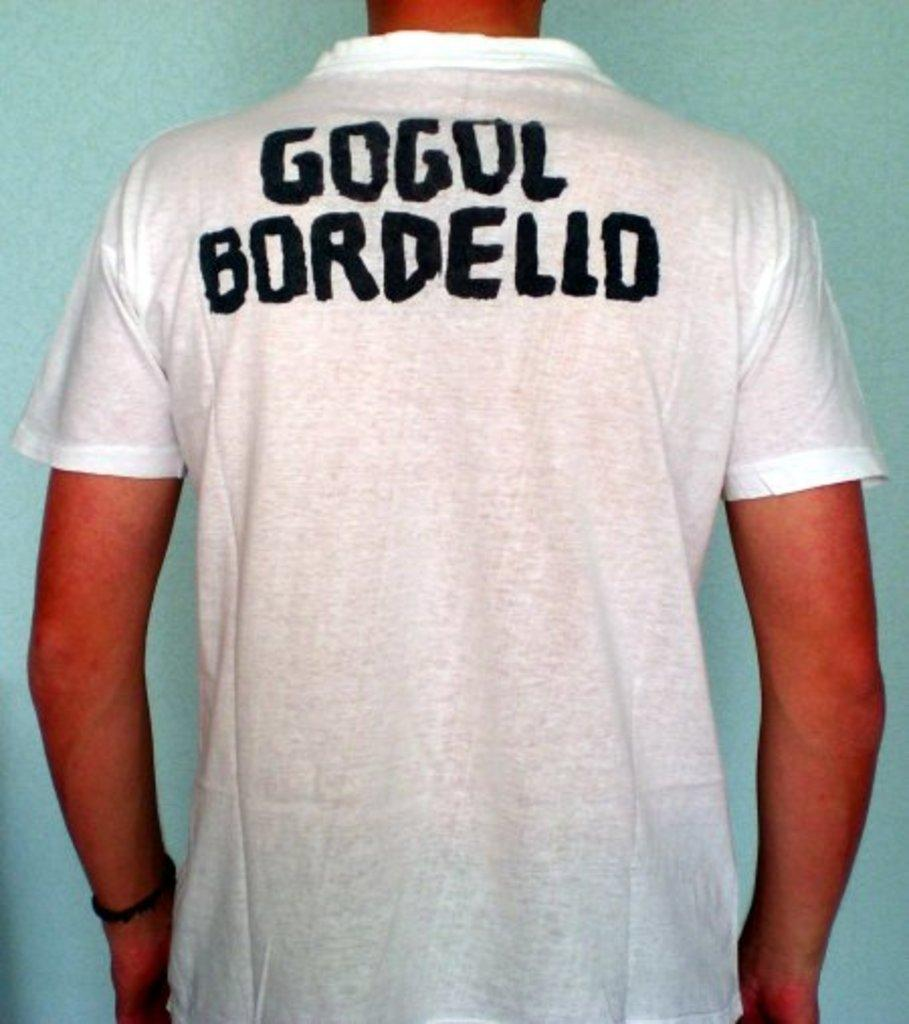<image>
Describe the image concisely. A man is wearing a white shirt that says Gogol Bordello on the back. 